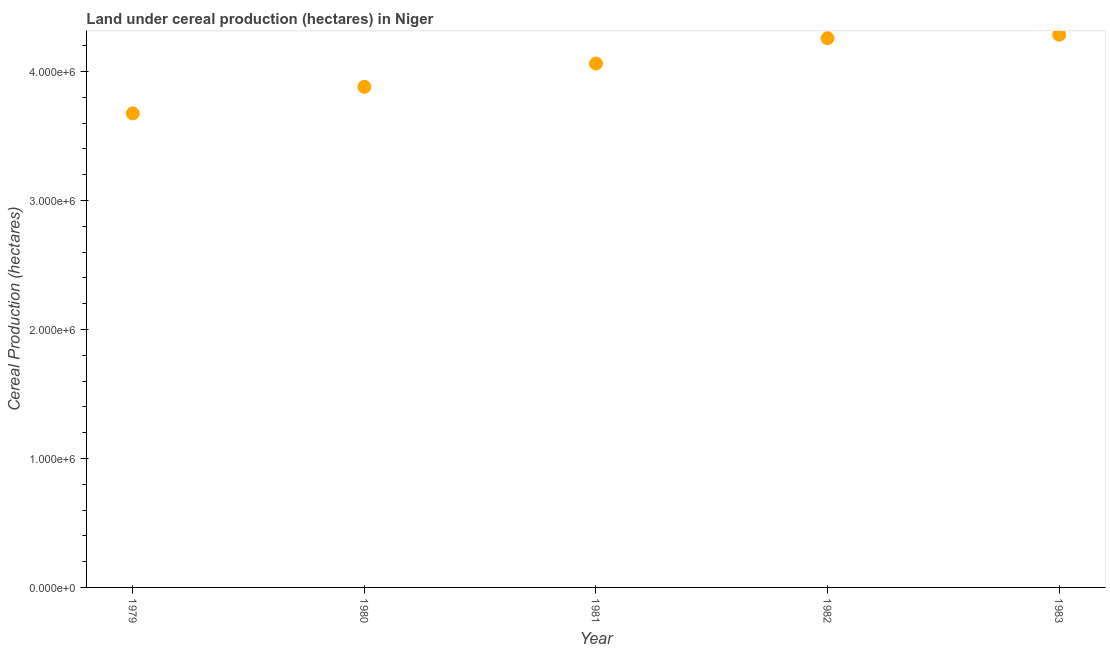What is the land under cereal production in 1983?
Your answer should be compact. 4.28e+06. Across all years, what is the maximum land under cereal production?
Offer a terse response. 4.28e+06. Across all years, what is the minimum land under cereal production?
Your answer should be compact. 3.67e+06. In which year was the land under cereal production maximum?
Offer a terse response. 1983. In which year was the land under cereal production minimum?
Offer a very short reply. 1979. What is the sum of the land under cereal production?
Ensure brevity in your answer.  2.02e+07. What is the difference between the land under cereal production in 1980 and 1983?
Your answer should be compact. -4.04e+05. What is the average land under cereal production per year?
Your answer should be very brief. 4.03e+06. What is the median land under cereal production?
Offer a terse response. 4.06e+06. What is the ratio of the land under cereal production in 1980 to that in 1981?
Your answer should be very brief. 0.96. Is the difference between the land under cereal production in 1980 and 1981 greater than the difference between any two years?
Keep it short and to the point. No. What is the difference between the highest and the second highest land under cereal production?
Make the answer very short. 2.70e+04. What is the difference between the highest and the lowest land under cereal production?
Offer a very short reply. 6.10e+05. In how many years, is the land under cereal production greater than the average land under cereal production taken over all years?
Give a very brief answer. 3. How many dotlines are there?
Offer a very short reply. 1. What is the difference between two consecutive major ticks on the Y-axis?
Make the answer very short. 1.00e+06. Does the graph contain any zero values?
Offer a very short reply. No. Does the graph contain grids?
Your answer should be compact. No. What is the title of the graph?
Give a very brief answer. Land under cereal production (hectares) in Niger. What is the label or title of the X-axis?
Ensure brevity in your answer.  Year. What is the label or title of the Y-axis?
Make the answer very short. Cereal Production (hectares). What is the Cereal Production (hectares) in 1979?
Ensure brevity in your answer.  3.67e+06. What is the Cereal Production (hectares) in 1980?
Provide a succinct answer. 3.88e+06. What is the Cereal Production (hectares) in 1981?
Offer a terse response. 4.06e+06. What is the Cereal Production (hectares) in 1982?
Provide a succinct answer. 4.26e+06. What is the Cereal Production (hectares) in 1983?
Provide a succinct answer. 4.28e+06. What is the difference between the Cereal Production (hectares) in 1979 and 1980?
Your answer should be very brief. -2.06e+05. What is the difference between the Cereal Production (hectares) in 1979 and 1981?
Provide a succinct answer. -3.87e+05. What is the difference between the Cereal Production (hectares) in 1979 and 1982?
Your answer should be very brief. -5.83e+05. What is the difference between the Cereal Production (hectares) in 1979 and 1983?
Make the answer very short. -6.10e+05. What is the difference between the Cereal Production (hectares) in 1980 and 1981?
Make the answer very short. -1.81e+05. What is the difference between the Cereal Production (hectares) in 1980 and 1982?
Provide a succinct answer. -3.77e+05. What is the difference between the Cereal Production (hectares) in 1980 and 1983?
Ensure brevity in your answer.  -4.04e+05. What is the difference between the Cereal Production (hectares) in 1981 and 1982?
Provide a succinct answer. -1.96e+05. What is the difference between the Cereal Production (hectares) in 1981 and 1983?
Give a very brief answer. -2.23e+05. What is the difference between the Cereal Production (hectares) in 1982 and 1983?
Your answer should be very brief. -2.70e+04. What is the ratio of the Cereal Production (hectares) in 1979 to that in 1980?
Your answer should be very brief. 0.95. What is the ratio of the Cereal Production (hectares) in 1979 to that in 1981?
Keep it short and to the point. 0.91. What is the ratio of the Cereal Production (hectares) in 1979 to that in 1982?
Make the answer very short. 0.86. What is the ratio of the Cereal Production (hectares) in 1979 to that in 1983?
Provide a succinct answer. 0.86. What is the ratio of the Cereal Production (hectares) in 1980 to that in 1981?
Your response must be concise. 0.95. What is the ratio of the Cereal Production (hectares) in 1980 to that in 1982?
Make the answer very short. 0.91. What is the ratio of the Cereal Production (hectares) in 1980 to that in 1983?
Give a very brief answer. 0.91. What is the ratio of the Cereal Production (hectares) in 1981 to that in 1982?
Your response must be concise. 0.95. What is the ratio of the Cereal Production (hectares) in 1981 to that in 1983?
Make the answer very short. 0.95. 